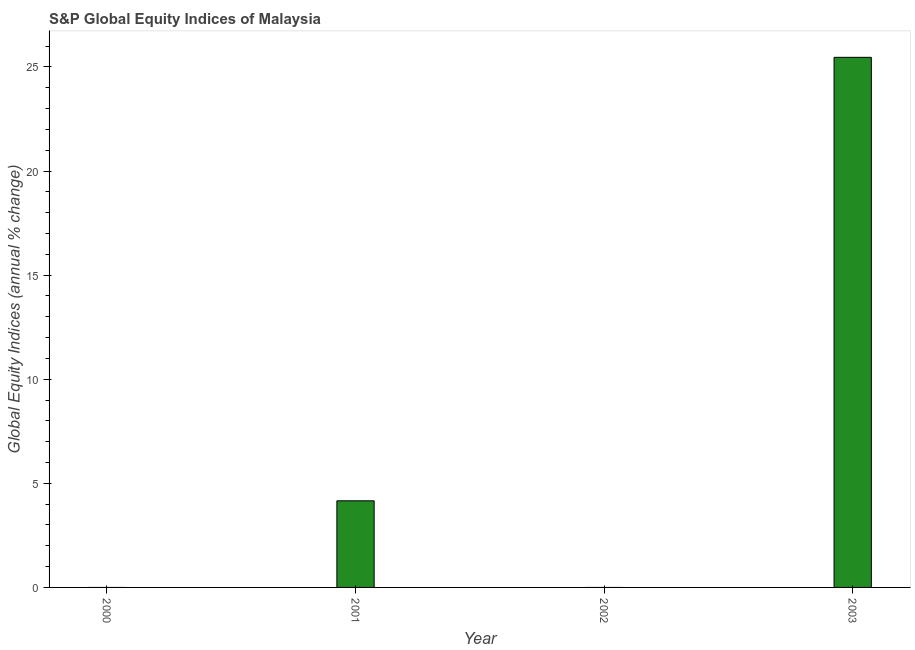Does the graph contain any zero values?
Offer a terse response. Yes. What is the title of the graph?
Keep it short and to the point. S&P Global Equity Indices of Malaysia. What is the label or title of the X-axis?
Give a very brief answer. Year. What is the label or title of the Y-axis?
Your response must be concise. Global Equity Indices (annual % change). What is the s&p global equity indices in 2002?
Provide a succinct answer. 0. Across all years, what is the maximum s&p global equity indices?
Make the answer very short. 25.46. In which year was the s&p global equity indices maximum?
Your answer should be compact. 2003. What is the sum of the s&p global equity indices?
Your answer should be very brief. 29.62. What is the difference between the s&p global equity indices in 2001 and 2003?
Give a very brief answer. -21.3. What is the average s&p global equity indices per year?
Provide a short and direct response. 7.41. What is the median s&p global equity indices?
Make the answer very short. 2.08. In how many years, is the s&p global equity indices greater than 23 %?
Your response must be concise. 1. What is the ratio of the s&p global equity indices in 2001 to that in 2003?
Provide a succinct answer. 0.16. Is the sum of the s&p global equity indices in 2001 and 2003 greater than the maximum s&p global equity indices across all years?
Offer a terse response. Yes. What is the difference between the highest and the lowest s&p global equity indices?
Give a very brief answer. 25.46. In how many years, is the s&p global equity indices greater than the average s&p global equity indices taken over all years?
Give a very brief answer. 1. How many bars are there?
Ensure brevity in your answer.  2. Are all the bars in the graph horizontal?
Offer a very short reply. No. What is the Global Equity Indices (annual % change) in 2001?
Your response must be concise. 4.16. What is the Global Equity Indices (annual % change) of 2003?
Your answer should be very brief. 25.46. What is the difference between the Global Equity Indices (annual % change) in 2001 and 2003?
Ensure brevity in your answer.  -21.3. What is the ratio of the Global Equity Indices (annual % change) in 2001 to that in 2003?
Provide a short and direct response. 0.16. 